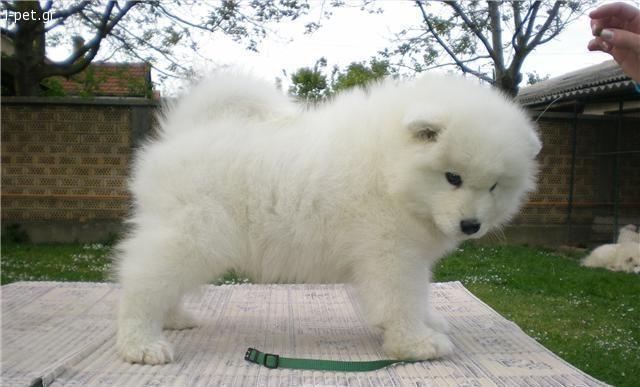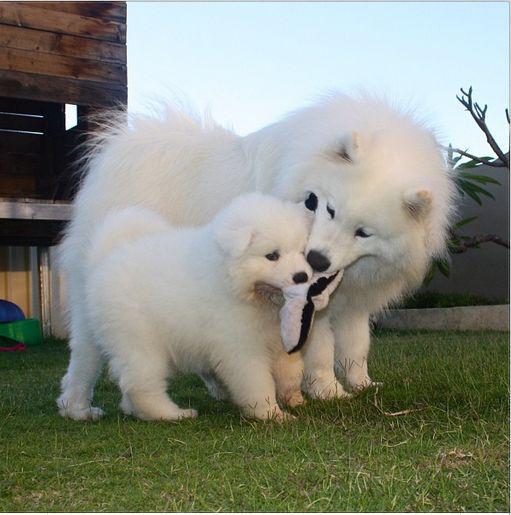The first image is the image on the left, the second image is the image on the right. Examine the images to the left and right. Is the description "Each image contains exactly one white dog, and each dog is in the same type of pose." accurate? Answer yes or no. No. The first image is the image on the left, the second image is the image on the right. Assess this claim about the two images: "Only one dog is contained in each image.". Correct or not? Answer yes or no. No. 